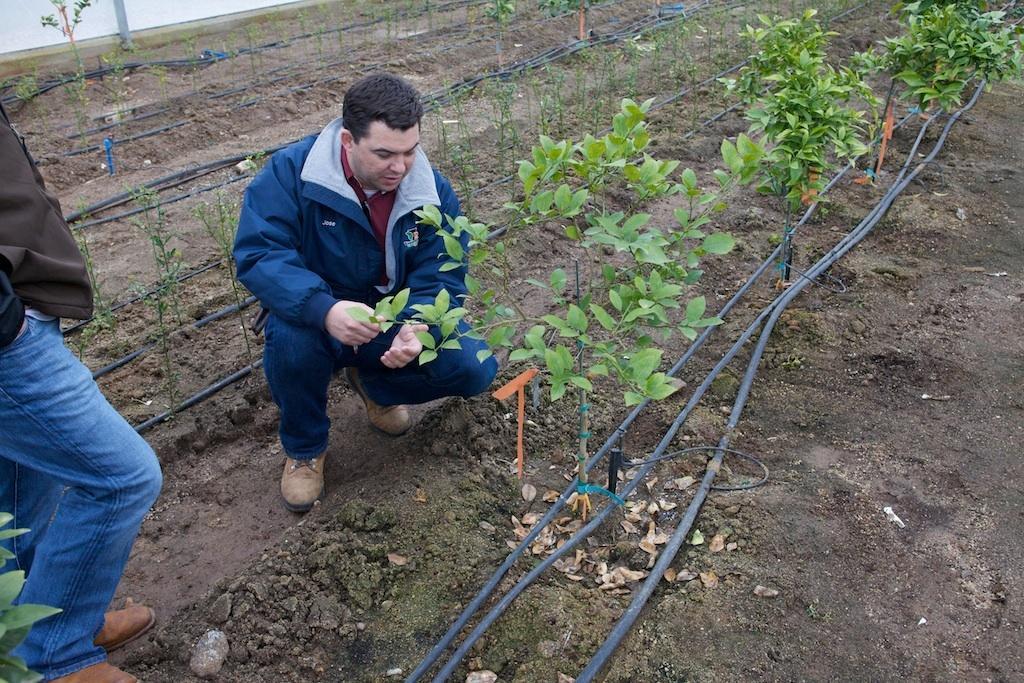How would you summarize this image in a sentence or two? In this image we can see there is a person holding a plant. There are plants, pipes and people. 